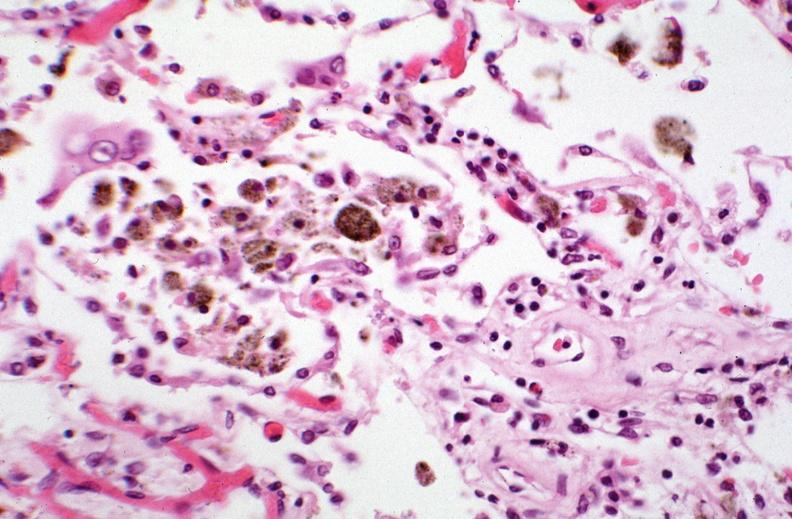what does this image show?
Answer the question using a single word or phrase. Lung 